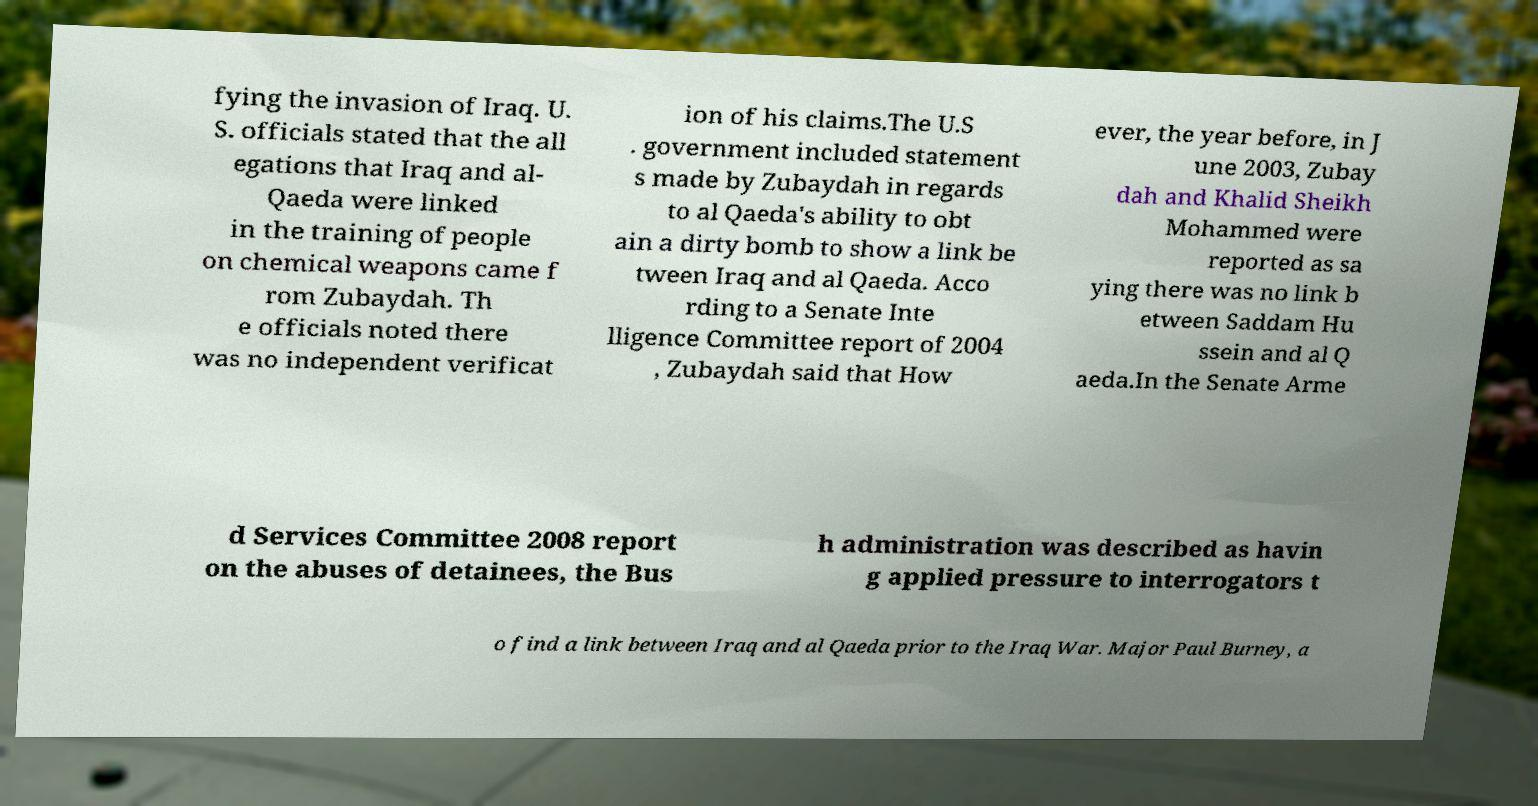Could you assist in decoding the text presented in this image and type it out clearly? fying the invasion of Iraq. U. S. officials stated that the all egations that Iraq and al- Qaeda were linked in the training of people on chemical weapons came f rom Zubaydah. Th e officials noted there was no independent verificat ion of his claims.The U.S . government included statement s made by Zubaydah in regards to al Qaeda's ability to obt ain a dirty bomb to show a link be tween Iraq and al Qaeda. Acco rding to a Senate Inte lligence Committee report of 2004 , Zubaydah said that How ever, the year before, in J une 2003, Zubay dah and Khalid Sheikh Mohammed were reported as sa ying there was no link b etween Saddam Hu ssein and al Q aeda.In the Senate Arme d Services Committee 2008 report on the abuses of detainees, the Bus h administration was described as havin g applied pressure to interrogators t o find a link between Iraq and al Qaeda prior to the Iraq War. Major Paul Burney, a 